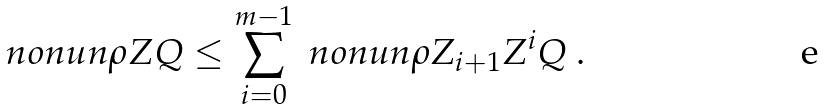Convert formula to latex. <formula><loc_0><loc_0><loc_500><loc_500>\ n o n u n { \rho } { Z } { Q } \leq \sum _ { i = 0 } ^ { m - 1 } \ n o n u n { \rho } { Z _ { i + 1 } } { Z ^ { i } Q } \ .</formula> 